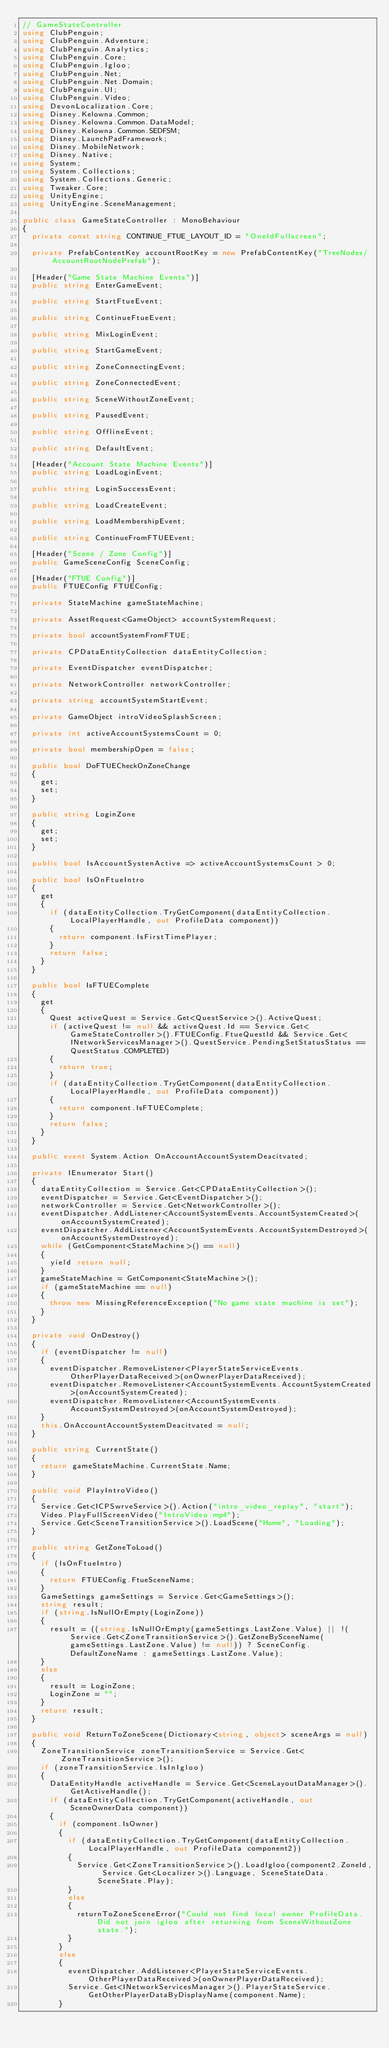Convert code to text. <code><loc_0><loc_0><loc_500><loc_500><_C#_>// GameStateController
using ClubPenguin;
using ClubPenguin.Adventure;
using ClubPenguin.Analytics;
using ClubPenguin.Core;
using ClubPenguin.Igloo;
using ClubPenguin.Net;
using ClubPenguin.Net.Domain;
using ClubPenguin.UI;
using ClubPenguin.Video;
using DevonLocalization.Core;
using Disney.Kelowna.Common;
using Disney.Kelowna.Common.DataModel;
using Disney.Kelowna.Common.SEDFSM;
using Disney.LaunchPadFramework;
using Disney.MobileNetwork;
using Disney.Native;
using System;
using System.Collections;
using System.Collections.Generic;
using Tweaker.Core;
using UnityEngine;
using UnityEngine.SceneManagement;

public class GameStateController : MonoBehaviour
{
	private const string CONTINUE_FTUE_LAYOUT_ID = "OneIdFullscreen";

	private PrefabContentKey accountRootKey = new PrefabContentKey("TreeNodes/AccountRootNodePrefab");

	[Header("Game State Machine Events")]
	public string EnterGameEvent;

	public string StartFtueEvent;

	public string ContinueFtueEvent;

	public string MixLoginEvent;

	public string StartGameEvent;

	public string ZoneConnectingEvent;

	public string ZoneConnectedEvent;

	public string SceneWithoutZoneEvent;

	public string PausedEvent;

	public string OfflineEvent;

	public string DefaultEvent;

	[Header("Account State Machine Events")]
	public string LoadLoginEvent;

	public string LoginSuccessEvent;

	public string LoadCreateEvent;

	public string LoadMembershipEvent;

	public string ContinueFromFTUEEvent;

	[Header("Scene / Zone Config")]
	public GameSceneConfig SceneConfig;

	[Header("FTUE Config")]
	public FTUEConfig FTUEConfig;

	private StateMachine gameStateMachine;

	private AssetRequest<GameObject> accountSystemRequest;

	private bool accountSystemFromFTUE;

	private CPDataEntityCollection dataEntityCollection;

	private EventDispatcher eventDispatcher;

	private NetworkController networkController;

	private string accountSystemStartEvent;

	private GameObject introVideoSplashScreen;

	private int activeAccountSystemsCount = 0;

	private bool membershipOpen = false;

	public bool DoFTUECheckOnZoneChange
	{
		get;
		set;
	}

	public string LoginZone
	{
		get;
		set;
	}

	public bool IsAccountSystenActive => activeAccountSystemsCount > 0;

	public bool IsOnFtueIntro
	{
		get
		{
			if (dataEntityCollection.TryGetComponent(dataEntityCollection.LocalPlayerHandle, out ProfileData component))
			{
				return component.IsFirstTimePlayer;
			}
			return false;
		}
	}

	public bool IsFTUEComplete
	{
		get
		{
			Quest activeQuest = Service.Get<QuestService>().ActiveQuest;
			if (activeQuest != null && activeQuest.Id == Service.Get<GameStateController>().FTUEConfig.FtueQuestId && Service.Get<INetworkServicesManager>().QuestService.PendingSetStatusStatus == QuestStatus.COMPLETED)
			{
				return true;
			}
			if (dataEntityCollection.TryGetComponent(dataEntityCollection.LocalPlayerHandle, out ProfileData component))
			{
				return component.IsFTUEComplete;
			}
			return false;
		}
	}

	public event System.Action OnAccountAccountSystemDeacitvated;

	private IEnumerator Start()
	{
		dataEntityCollection = Service.Get<CPDataEntityCollection>();
		eventDispatcher = Service.Get<EventDispatcher>();
		networkController = Service.Get<NetworkController>();
		eventDispatcher.AddListener<AccountSystemEvents.AccountSystemCreated>(onAccountSystemCreated);
		eventDispatcher.AddListener<AccountSystemEvents.AccountSystemDestroyed>(onAccountSystemDestroyed);
		while (GetComponent<StateMachine>() == null)
		{
			yield return null;
		}
		gameStateMachine = GetComponent<StateMachine>();
		if (gameStateMachine == null)
		{
			throw new MissingReferenceException("No game state machine is set");
		}
	}

	private void OnDestroy()
	{
		if (eventDispatcher != null)
		{
			eventDispatcher.RemoveListener<PlayerStateServiceEvents.OtherPlayerDataReceived>(onOwnerPlayerDataReceived);
			eventDispatcher.RemoveListener<AccountSystemEvents.AccountSystemCreated>(onAccountSystemCreated);
			eventDispatcher.RemoveListener<AccountSystemEvents.AccountSystemDestroyed>(onAccountSystemDestroyed);
		}
		this.OnAccountAccountSystemDeacitvated = null;
	}

	public string CurrentState()
	{
		return gameStateMachine.CurrentState.Name;
	}

	public void PlayIntroVideo()
	{
		Service.Get<ICPSwrveService>().Action("intro_video_replay", "start");
		Video.PlayFullScreenVideo("IntroVideo.mp4");
		Service.Get<SceneTransitionService>().LoadScene("Home", "Loading");
	}

	public string GetZoneToLoad()
	{
		if (IsOnFtueIntro)
		{
			return FTUEConfig.FtueSceneName;
		}
		GameSettings gameSettings = Service.Get<GameSettings>();
		string result;
		if (string.IsNullOrEmpty(LoginZone))
		{
			result = ((string.IsNullOrEmpty(gameSettings.LastZone.Value) || !(Service.Get<ZoneTransitionService>().GetZoneBySceneName(gameSettings.LastZone.Value) != null)) ? SceneConfig.DefaultZoneName : gameSettings.LastZone.Value);
		}
		else
		{
			result = LoginZone;
			LoginZone = "";
		}
		return result;
	}

	public void ReturnToZoneScene(Dictionary<string, object> sceneArgs = null)
	{
		ZoneTransitionService zoneTransitionService = Service.Get<ZoneTransitionService>();
		if (zoneTransitionService.IsInIgloo)
		{
			DataEntityHandle activeHandle = Service.Get<SceneLayoutDataManager>().GetActiveHandle();
			if (dataEntityCollection.TryGetComponent(activeHandle, out SceneOwnerData component))
			{
				if (component.IsOwner)
				{
					if (dataEntityCollection.TryGetComponent(dataEntityCollection.LocalPlayerHandle, out ProfileData component2))
					{
						Service.Get<ZoneTransitionService>().LoadIgloo(component2.ZoneId, Service.Get<Localizer>().Language, SceneStateData.SceneState.Play);
					}
					else
					{
						returnToZoneSceneError("Could not find local owner ProfileData. Did not join igloo after returning from SceneWithoutZone state.");
					}
				}
				else
				{
					eventDispatcher.AddListener<PlayerStateServiceEvents.OtherPlayerDataReceived>(onOwnerPlayerDataReceived);
					Service.Get<INetworkServicesManager>().PlayerStateService.GetOtherPlayerDataByDisplayName(component.Name);
				}</code> 